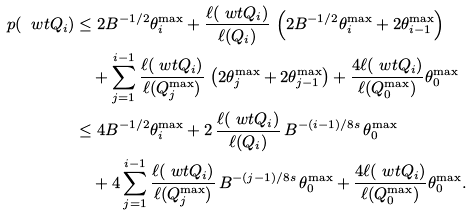<formula> <loc_0><loc_0><loc_500><loc_500>p ( \ w t Q _ { i } ) & \leq 2 B ^ { - 1 / 2 } \theta _ { i } ^ { \max } + \frac { \ell ( \ w t Q _ { i } ) } { \ell ( Q _ { i } ) } \, \left ( 2 B ^ { - 1 / 2 } \theta _ { i } ^ { \max } + 2 \theta _ { i - 1 } ^ { \max } \right ) \\ & \quad + \sum _ { j = 1 } ^ { i - 1 } \frac { \ell ( \ w t Q _ { i } ) } { \ell ( Q _ { j } ^ { \max } ) } \, \left ( 2 \theta _ { j } ^ { \max } + 2 \theta _ { j - 1 } ^ { \max } \right ) + \frac { 4 \ell ( \ w t Q _ { i } ) } { \ell ( Q _ { 0 } ^ { \max } ) } \theta _ { 0 } ^ { \max } \\ & \leq 4 B ^ { - 1 / 2 } \theta _ { i } ^ { \max } + 2 \, \frac { \ell ( \ w t Q _ { i } ) } { \ell ( Q _ { i } ) } \, B ^ { - ( i - 1 ) / 8 s } \, \theta _ { 0 } ^ { \max } \\ & \quad + 4 \sum _ { j = 1 } ^ { i - 1 } \frac { \ell ( \ w t Q _ { i } ) } { \ell ( Q _ { j } ^ { \max } ) } \, B ^ { - ( j - 1 ) / 8 s } \, \theta _ { 0 } ^ { \max } + \frac { 4 \ell ( \ w t Q _ { i } ) } { \ell ( Q _ { 0 } ^ { \max } ) } \theta _ { 0 } ^ { \max } .</formula> 